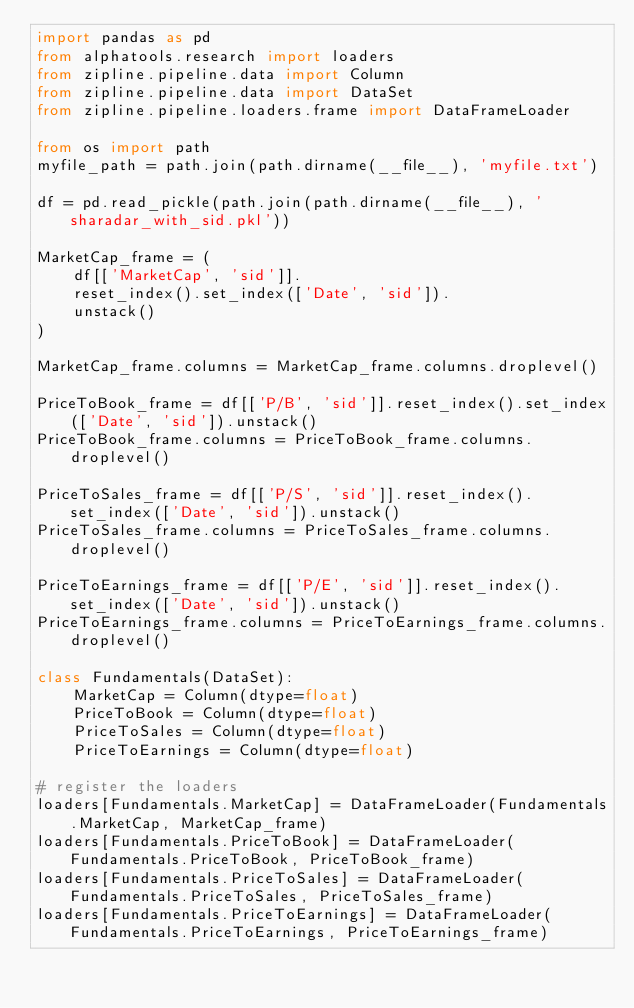Convert code to text. <code><loc_0><loc_0><loc_500><loc_500><_Python_>import pandas as pd
from alphatools.research import loaders
from zipline.pipeline.data import Column
from zipline.pipeline.data import DataSet
from zipline.pipeline.loaders.frame import DataFrameLoader

from os import path
myfile_path = path.join(path.dirname(__file__), 'myfile.txt')

df = pd.read_pickle(path.join(path.dirname(__file__), 'sharadar_with_sid.pkl'))

MarketCap_frame = (
    df[['MarketCap', 'sid']].
    reset_index().set_index(['Date', 'sid']).
    unstack()
)

MarketCap_frame.columns = MarketCap_frame.columns.droplevel()

PriceToBook_frame = df[['P/B', 'sid']].reset_index().set_index(['Date', 'sid']).unstack()
PriceToBook_frame.columns = PriceToBook_frame.columns.droplevel()

PriceToSales_frame = df[['P/S', 'sid']].reset_index().set_index(['Date', 'sid']).unstack()
PriceToSales_frame.columns = PriceToSales_frame.columns.droplevel()

PriceToEarnings_frame = df[['P/E', 'sid']].reset_index().set_index(['Date', 'sid']).unstack()
PriceToEarnings_frame.columns = PriceToEarnings_frame.columns.droplevel()

class Fundamentals(DataSet):
    MarketCap = Column(dtype=float)
    PriceToBook = Column(dtype=float)
    PriceToSales = Column(dtype=float)
    PriceToEarnings = Column(dtype=float)

# register the loaders
loaders[Fundamentals.MarketCap] = DataFrameLoader(Fundamentals.MarketCap, MarketCap_frame)
loaders[Fundamentals.PriceToBook] = DataFrameLoader(Fundamentals.PriceToBook, PriceToBook_frame)
loaders[Fundamentals.PriceToSales] = DataFrameLoader(Fundamentals.PriceToSales, PriceToSales_frame)
loaders[Fundamentals.PriceToEarnings] = DataFrameLoader(Fundamentals.PriceToEarnings, PriceToEarnings_frame)
</code> 